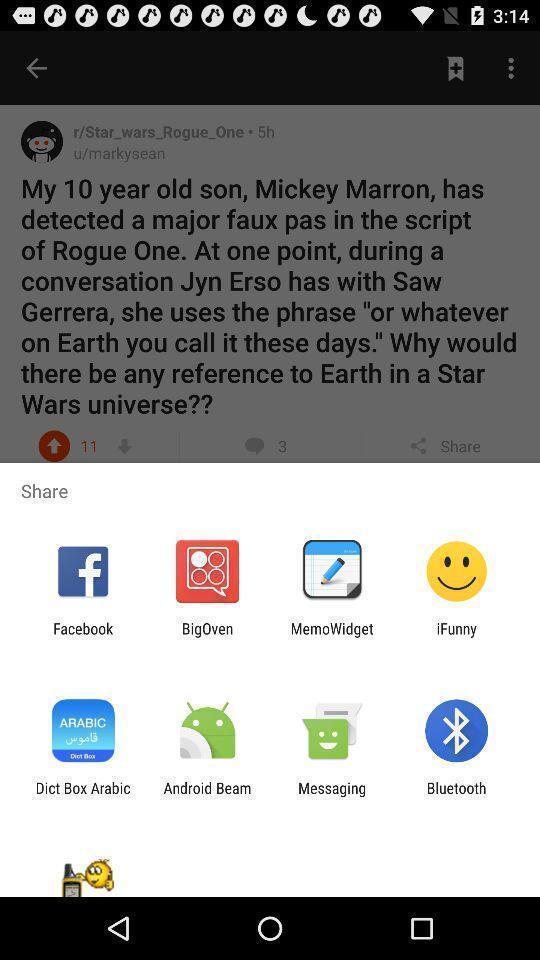Summarize the information in this screenshot. Pop-up for sharing with other selective social app. 